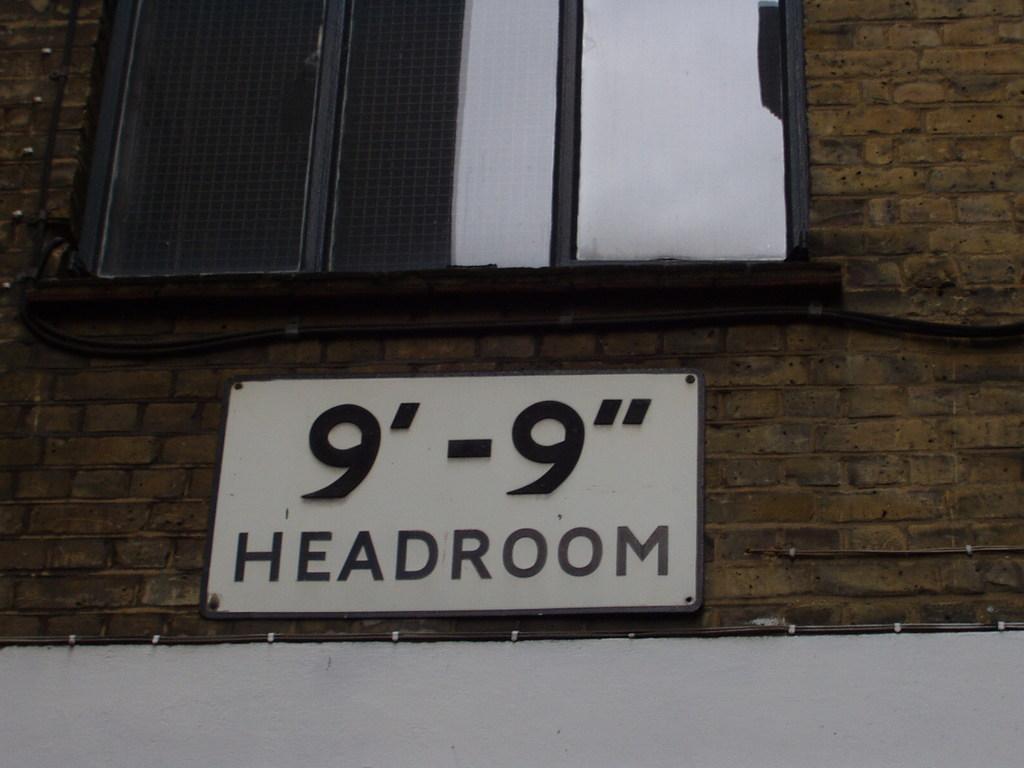In one or two sentences, can you explain what this image depicts? In this picture we can see a window and a name board on the wall. 